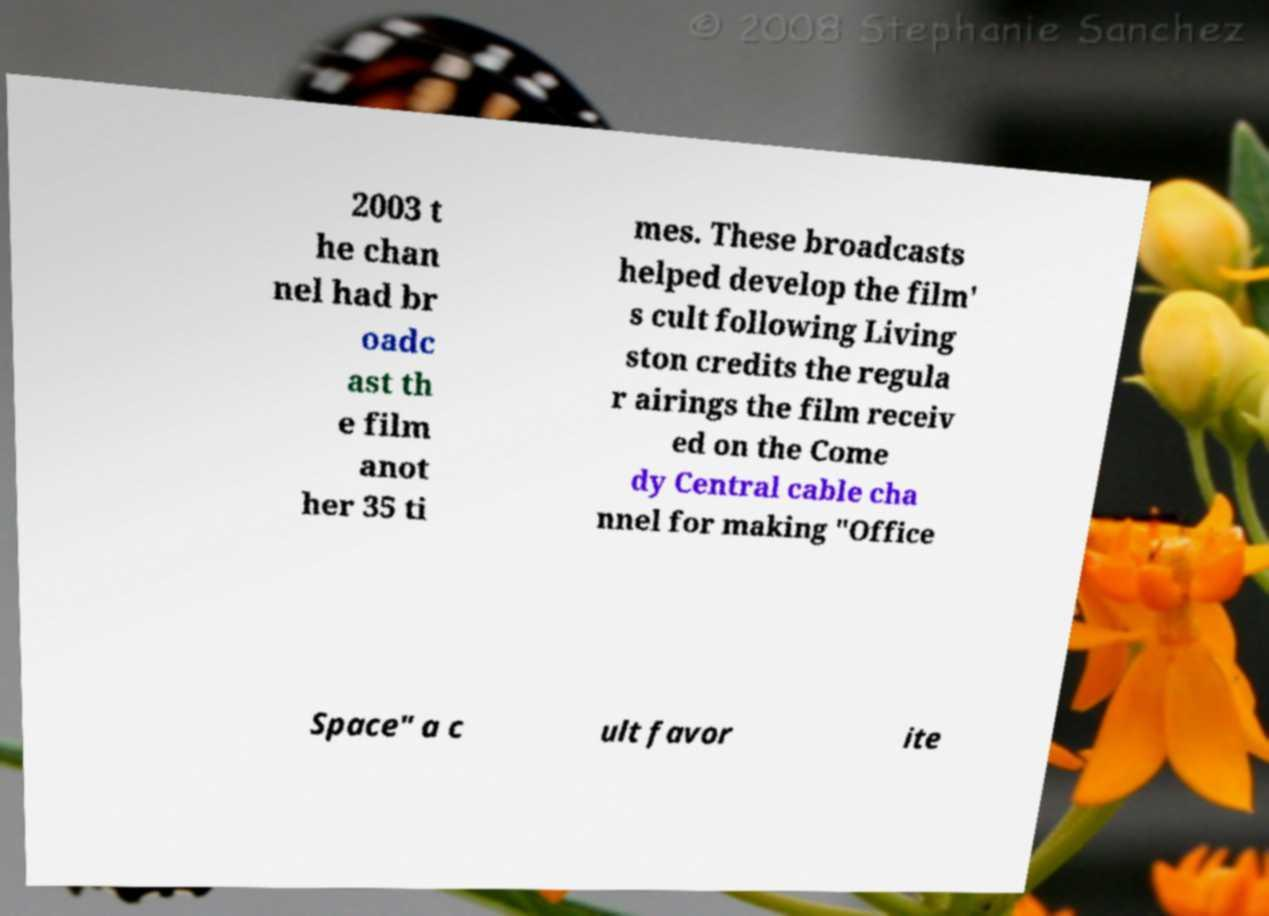I need the written content from this picture converted into text. Can you do that? 2003 t he chan nel had br oadc ast th e film anot her 35 ti mes. These broadcasts helped develop the film' s cult following Living ston credits the regula r airings the film receiv ed on the Come dy Central cable cha nnel for making "Office Space" a c ult favor ite 